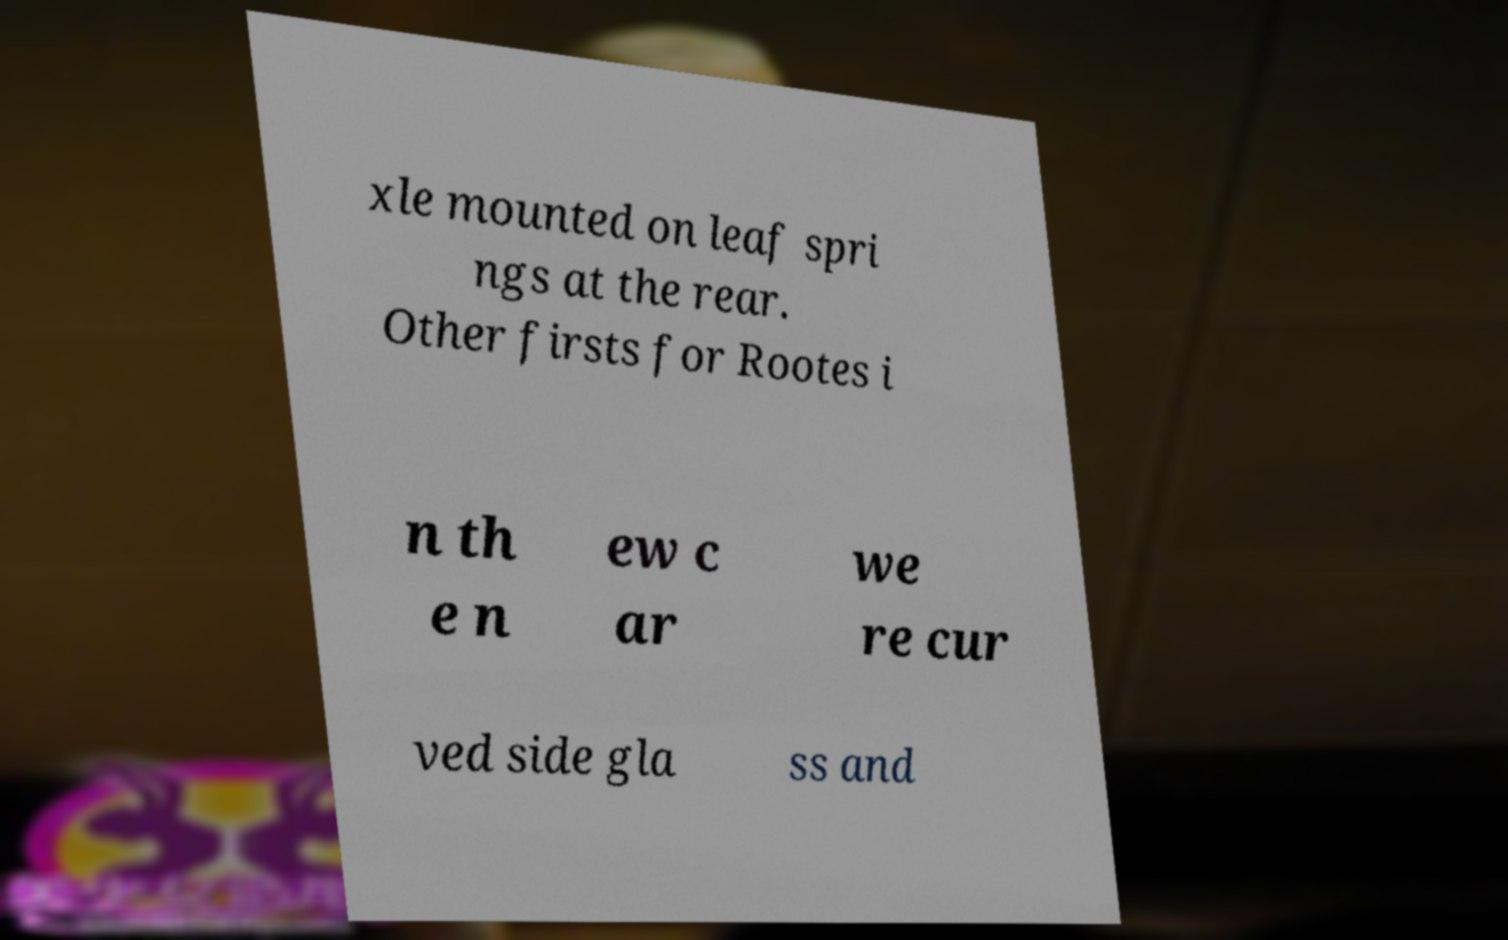I need the written content from this picture converted into text. Can you do that? xle mounted on leaf spri ngs at the rear. Other firsts for Rootes i n th e n ew c ar we re cur ved side gla ss and 